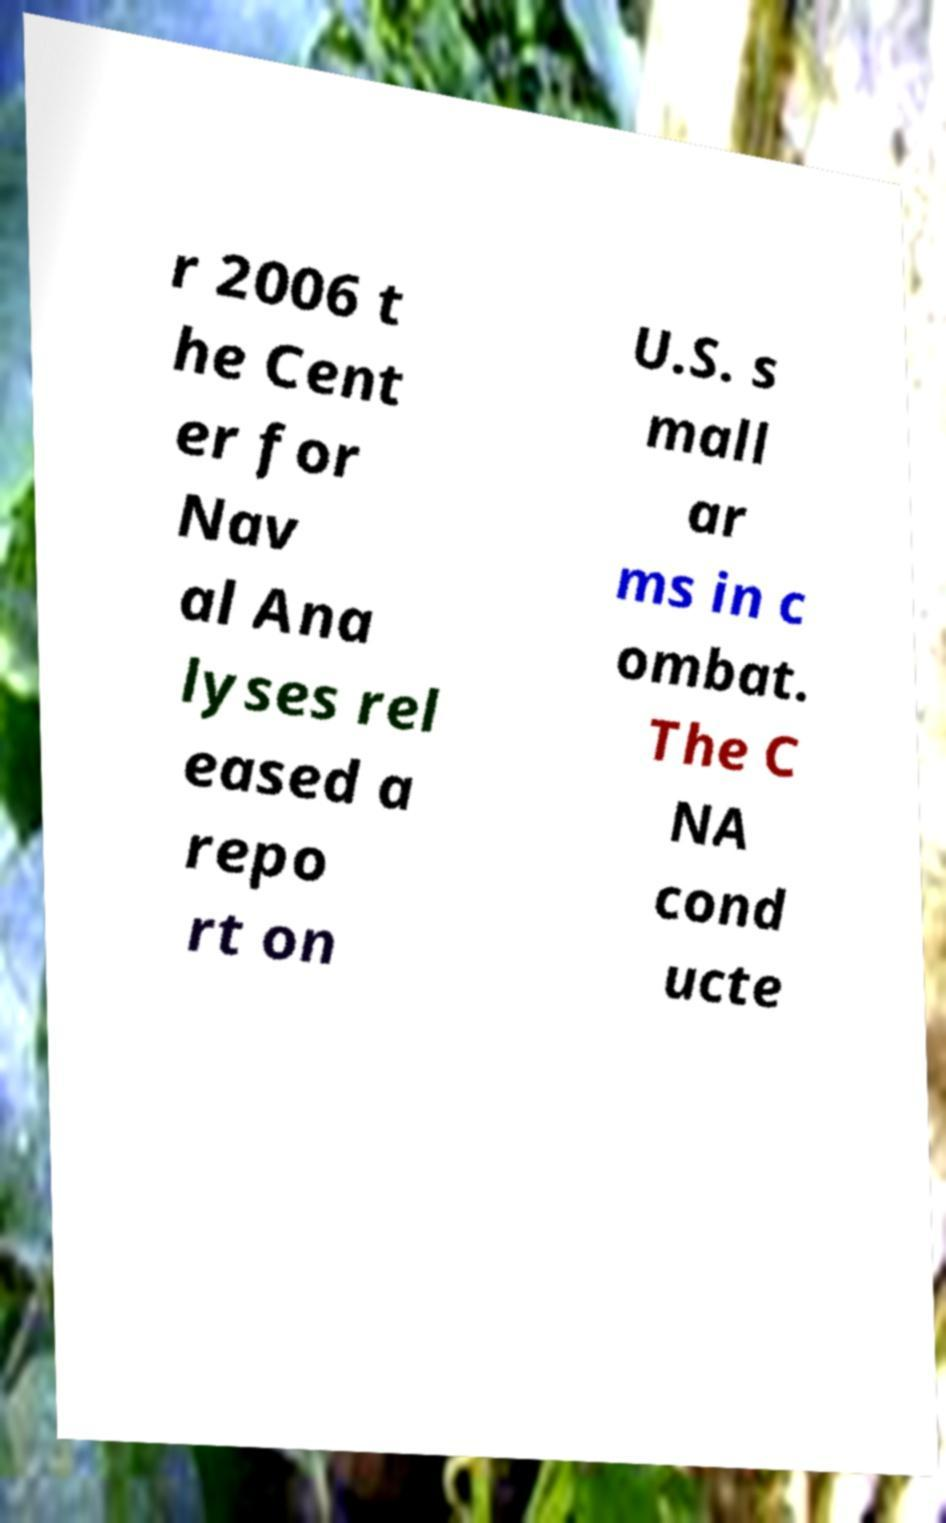There's text embedded in this image that I need extracted. Can you transcribe it verbatim? r 2006 t he Cent er for Nav al Ana lyses rel eased a repo rt on U.S. s mall ar ms in c ombat. The C NA cond ucte 